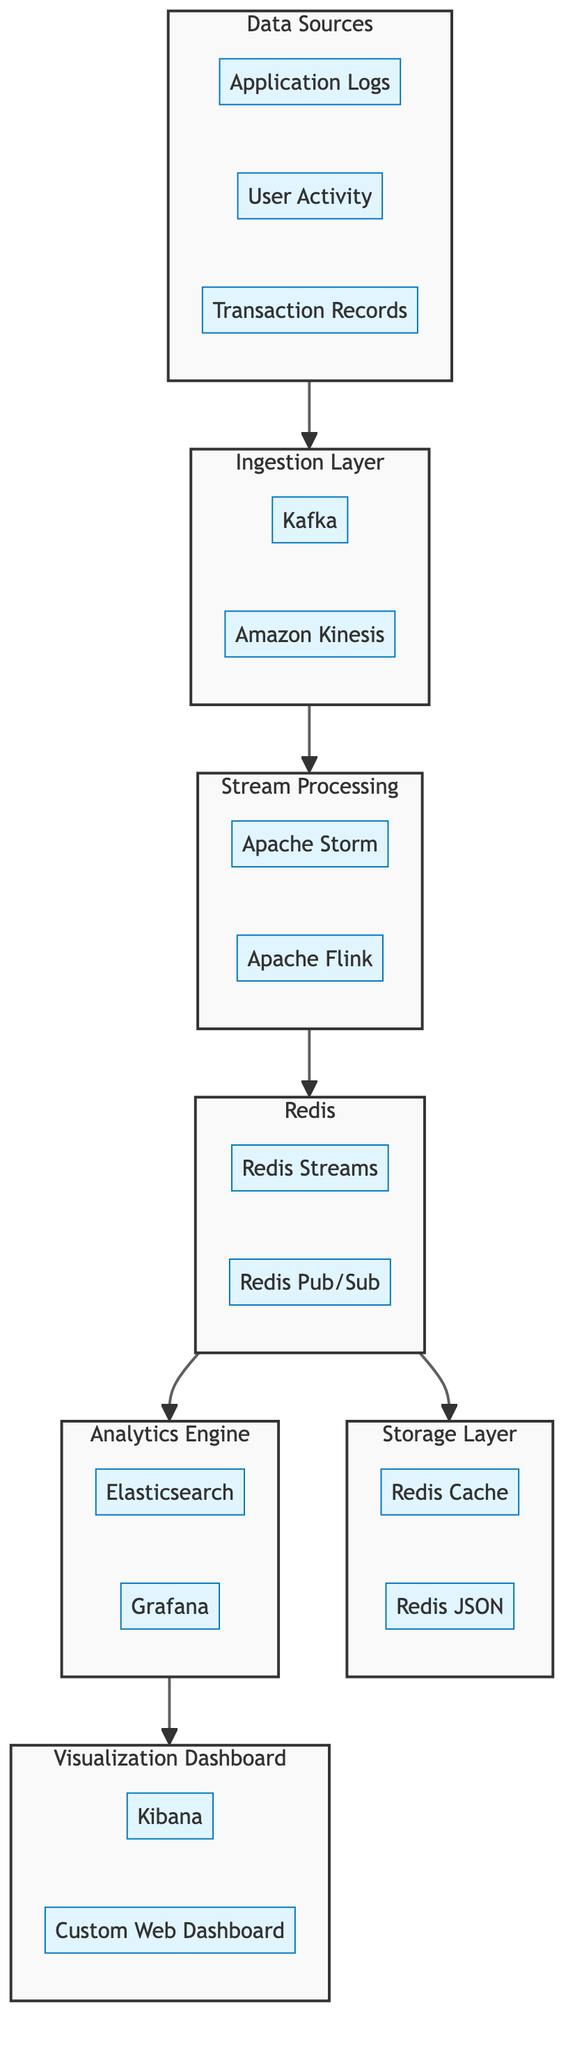What are the components of the Ingestion Layer? The Ingestion Layer consists of two components: Kafka and Amazon Kinesis.
Answer: Kafka, Amazon Kinesis How many components are in the Storage Layer? The Storage Layer contains two components: Redis Cache and Redis JSON.
Answer: 2 What connects the Stream Processing block to the Redis block? The arrow flowing from Stream Processing to Redis indicates that the output of Stream Processing is directed into Redis.
Answer: Redis Which components are part of the Redis block? The Redis block has two components: Redis Streams and Redis Pub/Sub.
Answer: Redis Streams, Redis Pub/Sub How many total blocks are present in the diagram? The diagram contains six distinct blocks: Data Sources, Ingestion Layer, Stream Processing, Redis, Storage Layer, Analytics Engine, and Visualization Dashboard.
Answer: 7 What is the flow direction from the Analytics Engine to the Visualization Dashboard? The flow is directed from the Analytics Engine to the Visualization Dashboard, indicating that the analytics results are visualized in the dashboard.
Answer: Forward List the components within the Visualization Dashboard. The Visualization Dashboard has two components: Kibana and Custom Web Dashboard.
Answer: Kibana, Custom Web Dashboard Which component in the Stream Processing block is used for real-time processing? Both Apache Storm and Apache Flink in the Stream Processing block are utilized for real-time data processing.
Answer: Apache Storm, Apache Flink What is the source of data for the Data Sources block? The Data Sources block is fed by three types of data: Application Logs, User Activity, and Transaction Records.
Answer: Application Logs, User Activity, Transaction Records 